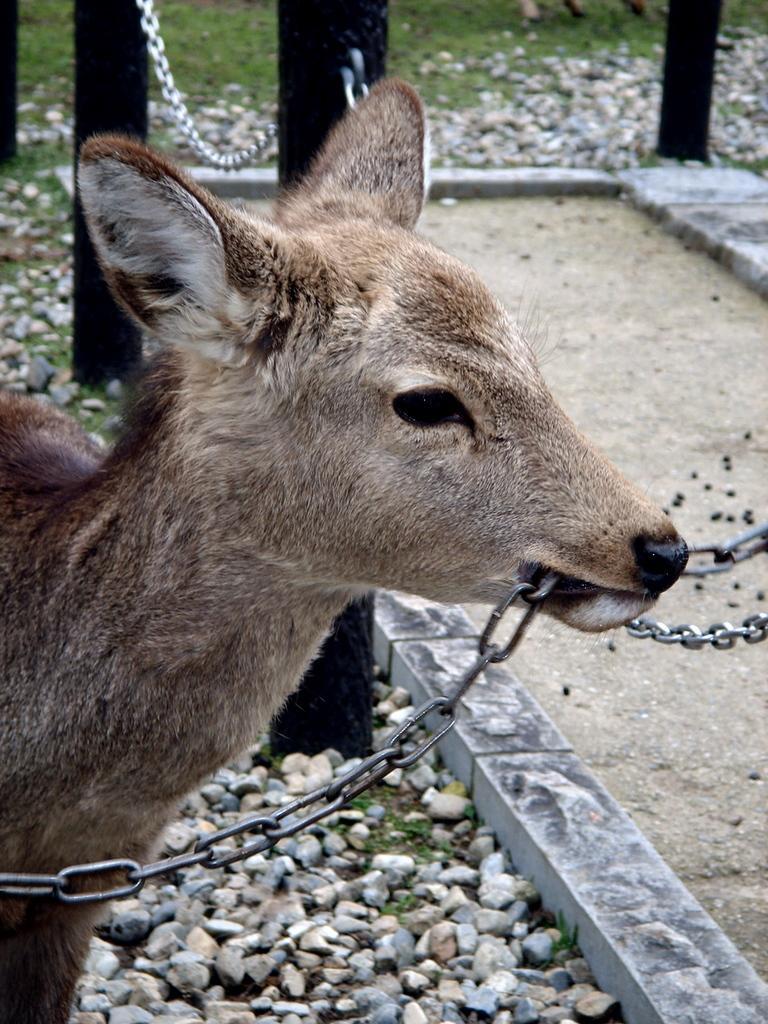Describe this image in one or two sentences. In this image, we can see chain in the mouth of deer. Background we can see stones, rods, chain and grass. Here we can see walkway. 